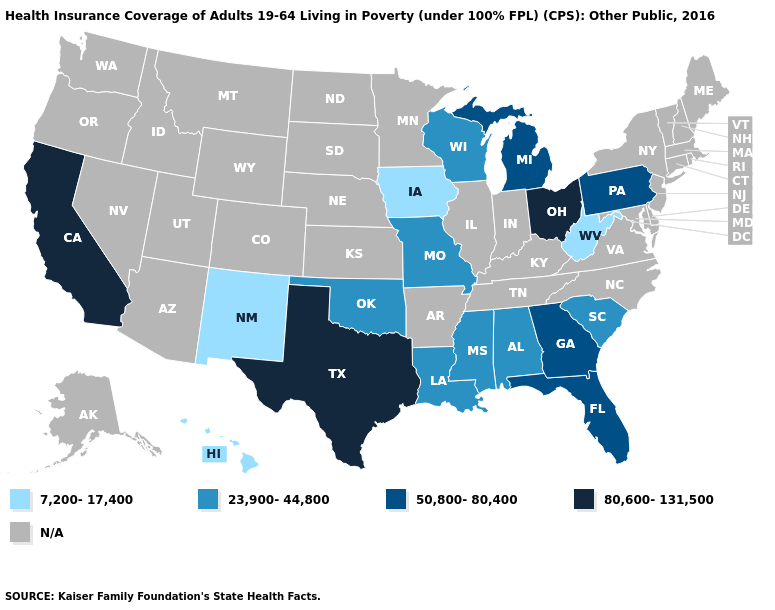What is the lowest value in the USA?
Be succinct. 7,200-17,400. Which states hav the highest value in the South?
Give a very brief answer. Texas. What is the value of Missouri?
Answer briefly. 23,900-44,800. Which states have the highest value in the USA?
Give a very brief answer. California, Ohio, Texas. What is the value of Nebraska?
Write a very short answer. N/A. Name the states that have a value in the range 7,200-17,400?
Keep it brief. Hawaii, Iowa, New Mexico, West Virginia. What is the lowest value in the USA?
Write a very short answer. 7,200-17,400. What is the highest value in states that border Alabama?
Answer briefly. 50,800-80,400. What is the value of Maine?
Short answer required. N/A. Does the first symbol in the legend represent the smallest category?
Be succinct. Yes. What is the value of Tennessee?
Keep it brief. N/A. What is the value of Delaware?
Quick response, please. N/A. Name the states that have a value in the range N/A?
Give a very brief answer. Alaska, Arizona, Arkansas, Colorado, Connecticut, Delaware, Idaho, Illinois, Indiana, Kansas, Kentucky, Maine, Maryland, Massachusetts, Minnesota, Montana, Nebraska, Nevada, New Hampshire, New Jersey, New York, North Carolina, North Dakota, Oregon, Rhode Island, South Dakota, Tennessee, Utah, Vermont, Virginia, Washington, Wyoming. Name the states that have a value in the range N/A?
Concise answer only. Alaska, Arizona, Arkansas, Colorado, Connecticut, Delaware, Idaho, Illinois, Indiana, Kansas, Kentucky, Maine, Maryland, Massachusetts, Minnesota, Montana, Nebraska, Nevada, New Hampshire, New Jersey, New York, North Carolina, North Dakota, Oregon, Rhode Island, South Dakota, Tennessee, Utah, Vermont, Virginia, Washington, Wyoming. What is the lowest value in the USA?
Write a very short answer. 7,200-17,400. 